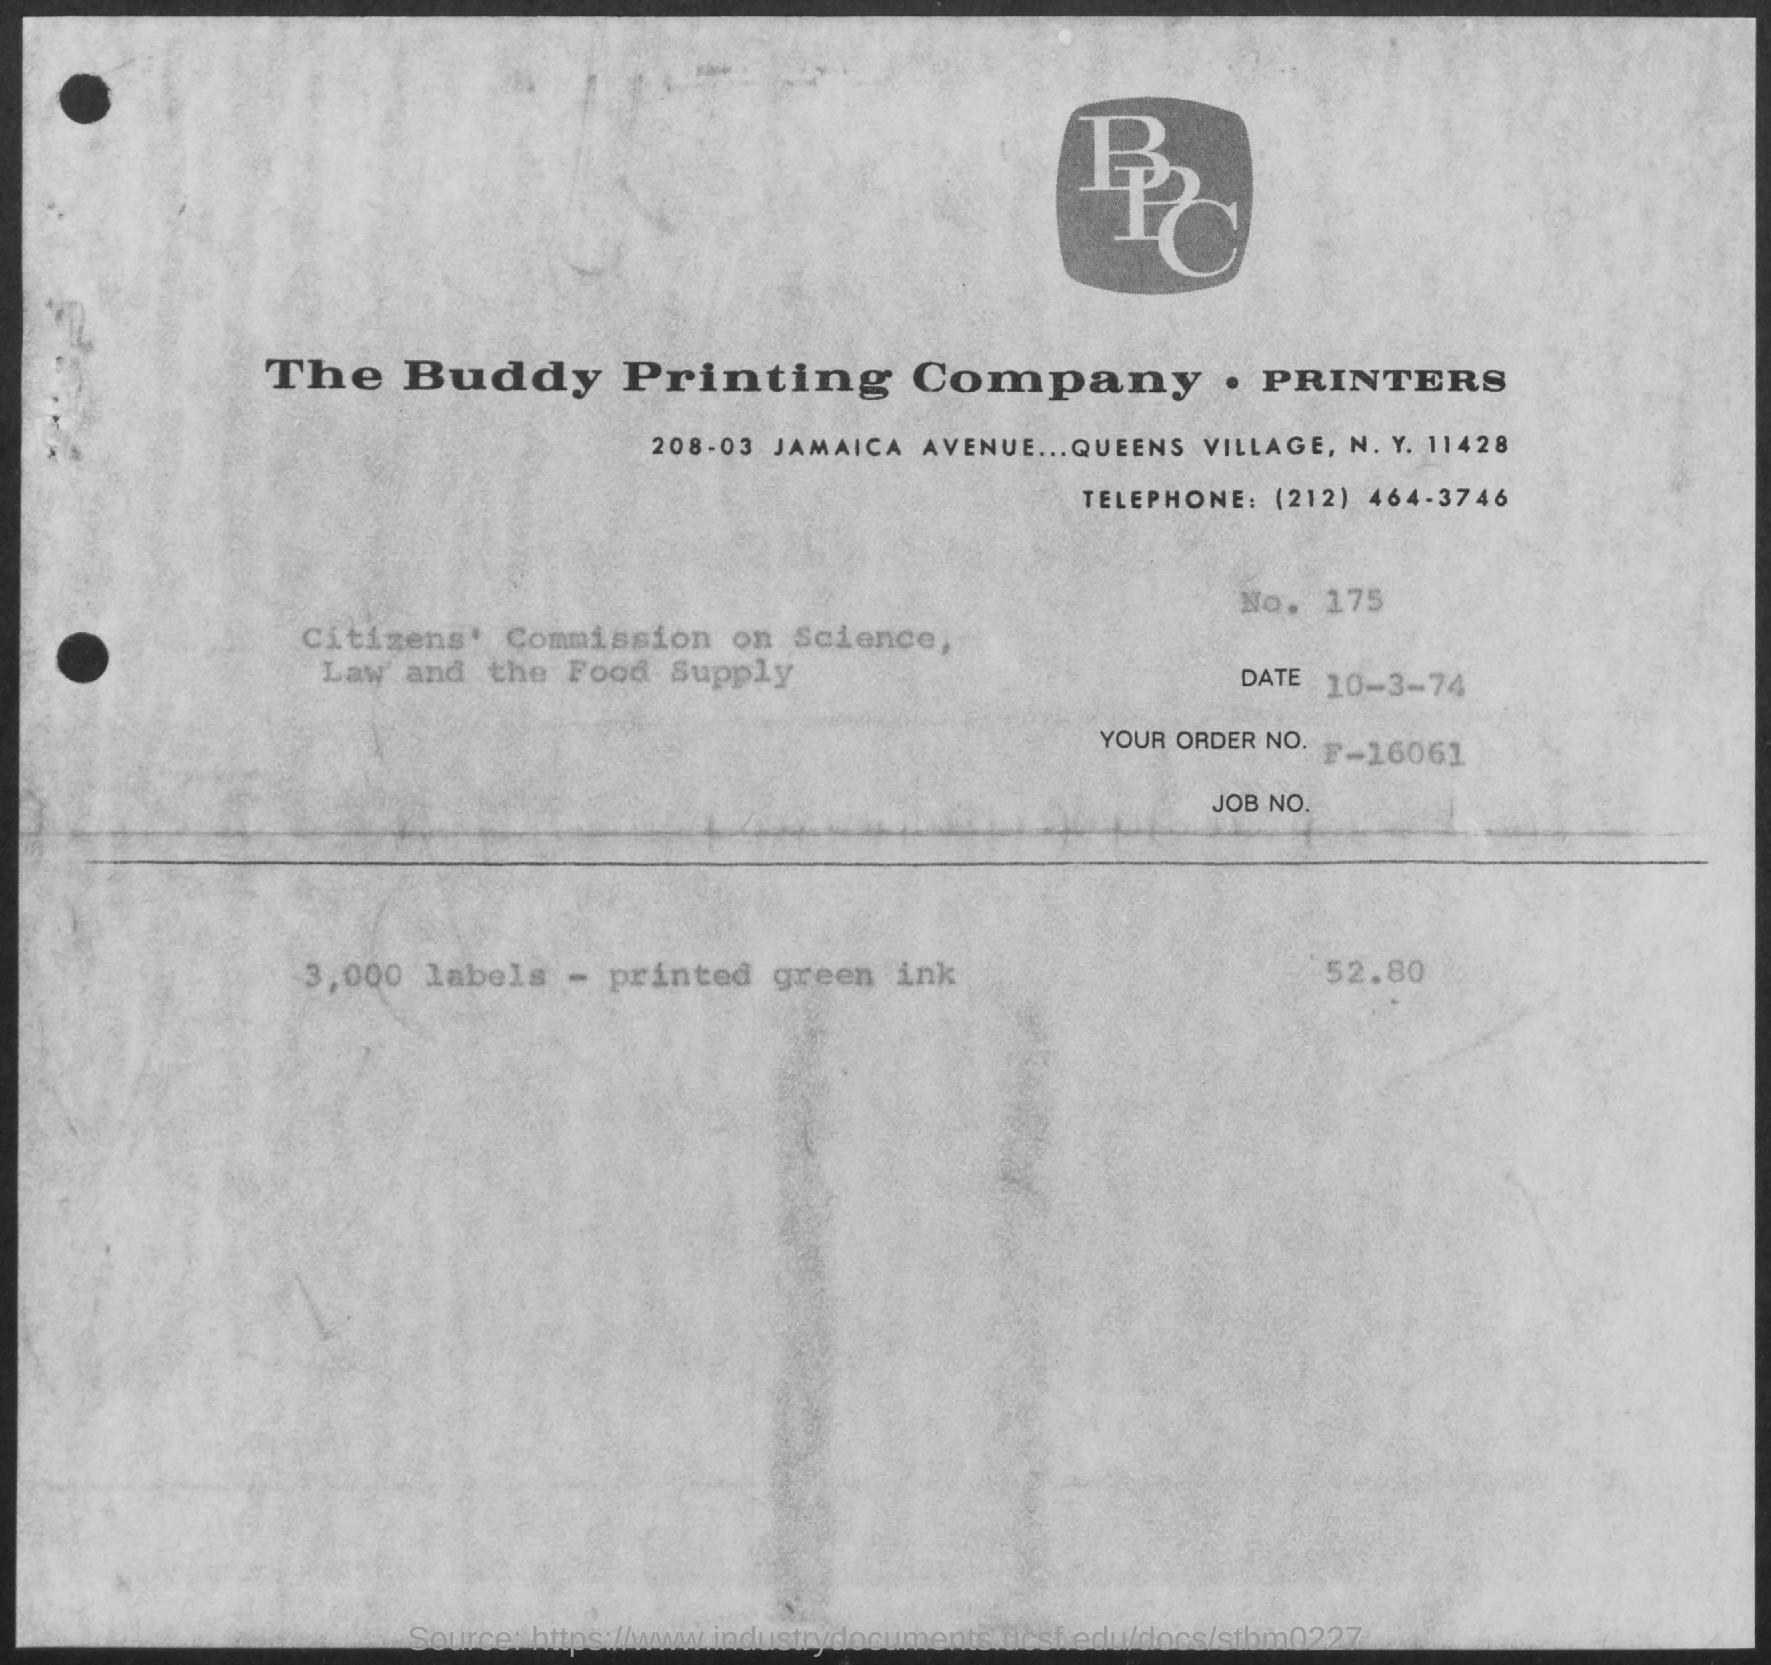Indicate a few pertinent items in this graphic. The order number is F-16061. What is the date? The date is October 3, 1974. 